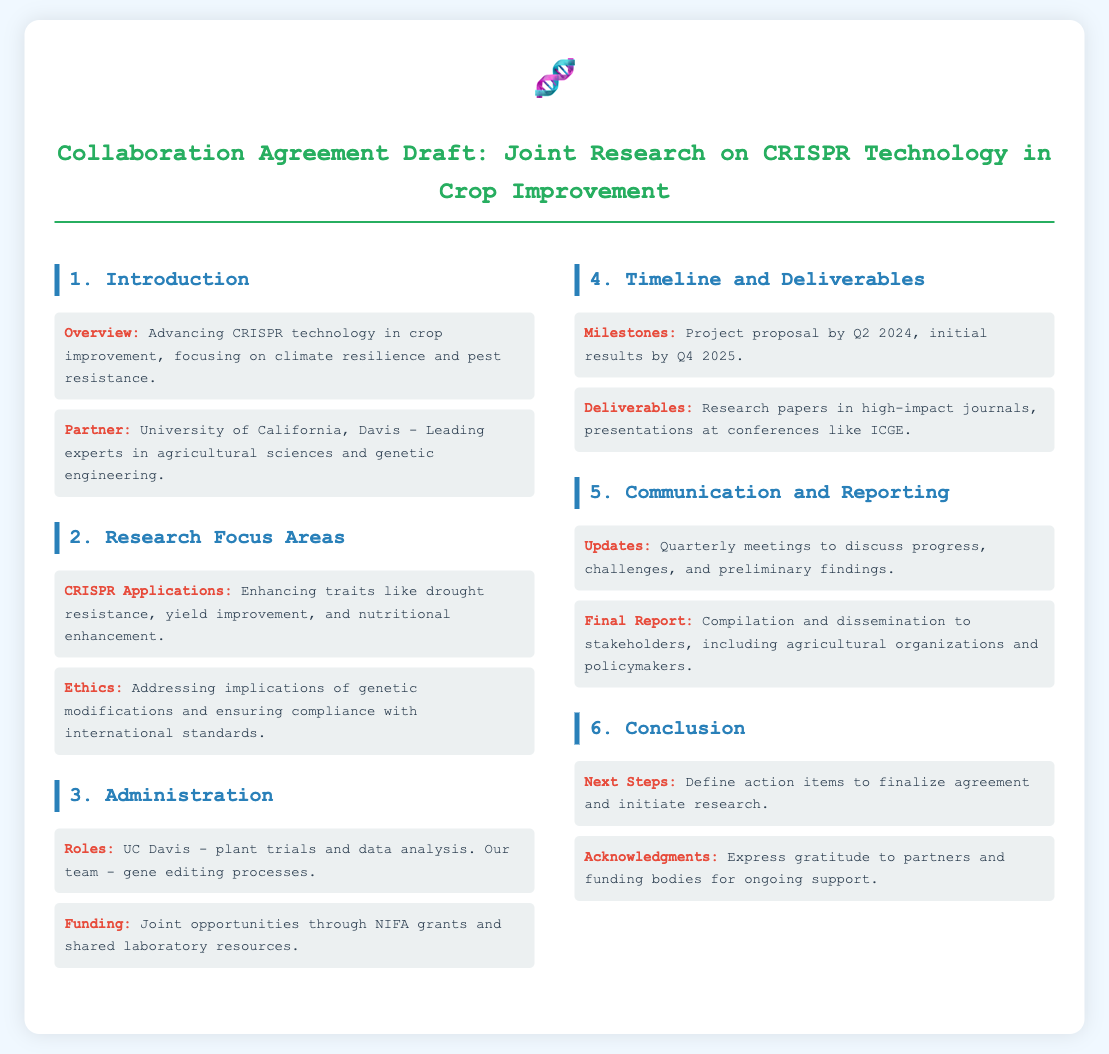what is the main focus of the collaboration? The main focus is on advancing CRISPR technology in crop improvement, particularly regarding climate resilience and pest resistance.
Answer: advancing CRISPR technology in crop improvement, focusing on climate resilience and pest resistance who is the partner university? The document specifies the partner university as UC Davis, which is known for its expertise in agricultural sciences and genetic engineering.
Answer: University of California, Davis what are the initial results expected? The document outlines that initial results are expected by the fourth quarter of 2025.
Answer: Q4 2025 what are the roles defined in the administration section? The roles specified are that UC Davis will handle plant trials and data analysis while our team will focus on gene editing processes.
Answer: UC Davis - plant trials and data analysis; Our team - gene editing processes what type of grants are mentioned for funding opportunities? The document refers to joint opportunities through NIFA grants for funding the research activities.
Answer: NIFA grants what is the timeline for the project proposal? According to the document, the project proposal is scheduled for the second quarter of 2024.
Answer: Q2 2024 how often will updates be provided? The document states that there will be quarterly meetings to discuss progress and challenges.
Answer: Quarterly meetings what should the final report include? The final report will include a compilation and dissemination to stakeholders such as agricultural organizations and policymakers.
Answer: Compilation and dissemination to stakeholders what is the purpose of the acknowledgments section? The acknowledgments section expresses gratitude to partners and funding bodies for their support throughout the research.
Answer: Express gratitude to partners and funding bodies for ongoing support 